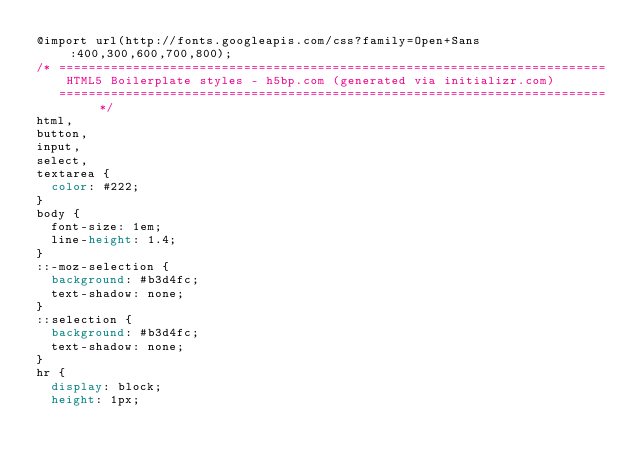<code> <loc_0><loc_0><loc_500><loc_500><_CSS_>@import url(http://fonts.googleapis.com/css?family=Open+Sans:400,300,600,700,800);
/* ==========================================================================
    HTML5 Boilerplate styles - h5bp.com (generated via initializr.com)
   ========================================================================== */
html,
button,
input,
select,
textarea {
  color: #222;
}
body {
  font-size: 1em;
  line-height: 1.4;
}
::-moz-selection {
  background: #b3d4fc;
  text-shadow: none;
}
::selection {
  background: #b3d4fc;
  text-shadow: none;
}
hr {
  display: block;
  height: 1px;</code> 